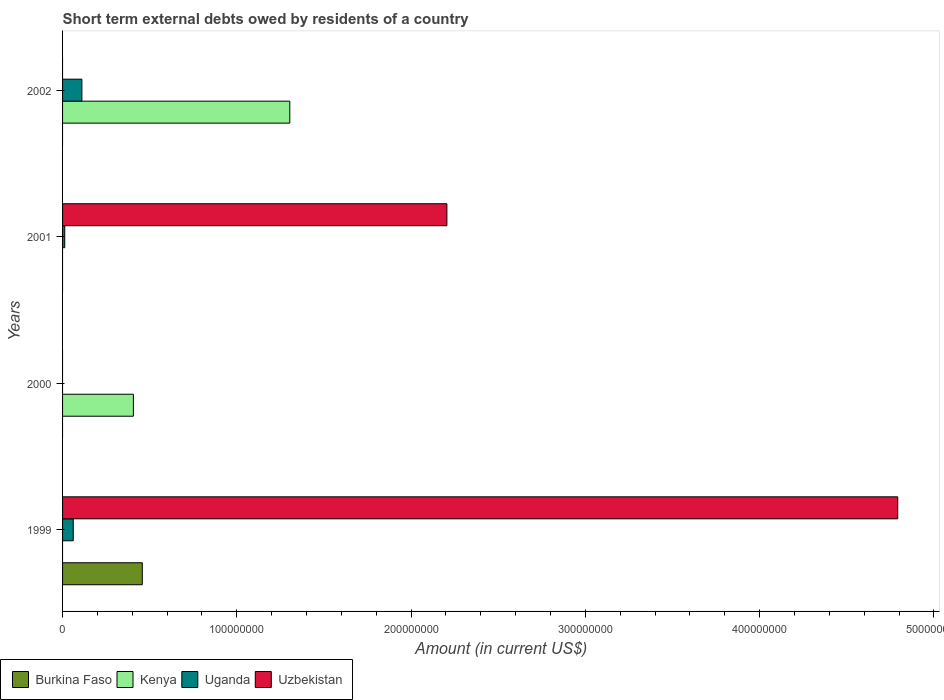Are the number of bars on each tick of the Y-axis equal?
Provide a succinct answer. No. How many bars are there on the 4th tick from the top?
Provide a short and direct response. 3. What is the amount of short-term external debts owed by residents in Kenya in 2002?
Make the answer very short. 1.30e+08. Across all years, what is the maximum amount of short-term external debts owed by residents in Uzbekistan?
Your answer should be compact. 4.79e+08. In which year was the amount of short-term external debts owed by residents in Uganda maximum?
Make the answer very short. 2002. What is the total amount of short-term external debts owed by residents in Uganda in the graph?
Provide a short and direct response. 1.85e+07. What is the difference between the amount of short-term external debts owed by residents in Uganda in 1999 and that in 2002?
Make the answer very short. -4.96e+06. What is the difference between the amount of short-term external debts owed by residents in Uganda in 2000 and the amount of short-term external debts owed by residents in Burkina Faso in 1999?
Offer a very short reply. -4.58e+07. What is the average amount of short-term external debts owed by residents in Uzbekistan per year?
Make the answer very short. 1.75e+08. In the year 2002, what is the difference between the amount of short-term external debts owed by residents in Kenya and amount of short-term external debts owed by residents in Uganda?
Ensure brevity in your answer.  1.19e+08. What is the ratio of the amount of short-term external debts owed by residents in Kenya in 2000 to that in 2002?
Offer a terse response. 0.31. What is the difference between the highest and the second highest amount of short-term external debts owed by residents in Uganda?
Your answer should be very brief. 4.96e+06. What is the difference between the highest and the lowest amount of short-term external debts owed by residents in Uganda?
Provide a short and direct response. 1.11e+07. In how many years, is the amount of short-term external debts owed by residents in Uzbekistan greater than the average amount of short-term external debts owed by residents in Uzbekistan taken over all years?
Ensure brevity in your answer.  2. Is the sum of the amount of short-term external debts owed by residents in Kenya in 2000 and 2002 greater than the maximum amount of short-term external debts owed by residents in Uganda across all years?
Provide a short and direct response. Yes. Is it the case that in every year, the sum of the amount of short-term external debts owed by residents in Uganda and amount of short-term external debts owed by residents in Burkina Faso is greater than the sum of amount of short-term external debts owed by residents in Uzbekistan and amount of short-term external debts owed by residents in Kenya?
Offer a terse response. No. Is it the case that in every year, the sum of the amount of short-term external debts owed by residents in Uganda and amount of short-term external debts owed by residents in Kenya is greater than the amount of short-term external debts owed by residents in Burkina Faso?
Your answer should be very brief. No. How many bars are there?
Give a very brief answer. 8. Are all the bars in the graph horizontal?
Provide a succinct answer. Yes. How many years are there in the graph?
Offer a terse response. 4. Does the graph contain any zero values?
Your response must be concise. Yes. How many legend labels are there?
Your response must be concise. 4. What is the title of the graph?
Keep it short and to the point. Short term external debts owed by residents of a country. Does "Fragile and conflict affected situations" appear as one of the legend labels in the graph?
Ensure brevity in your answer.  No. What is the label or title of the Y-axis?
Provide a succinct answer. Years. What is the Amount (in current US$) in Burkina Faso in 1999?
Offer a very short reply. 4.58e+07. What is the Amount (in current US$) in Uganda in 1999?
Your response must be concise. 6.13e+06. What is the Amount (in current US$) of Uzbekistan in 1999?
Your answer should be compact. 4.79e+08. What is the Amount (in current US$) of Burkina Faso in 2000?
Offer a terse response. 0. What is the Amount (in current US$) of Kenya in 2000?
Keep it short and to the point. 4.06e+07. What is the Amount (in current US$) of Kenya in 2001?
Provide a succinct answer. 0. What is the Amount (in current US$) in Uganda in 2001?
Provide a succinct answer. 1.24e+06. What is the Amount (in current US$) in Uzbekistan in 2001?
Offer a very short reply. 2.21e+08. What is the Amount (in current US$) of Kenya in 2002?
Offer a very short reply. 1.30e+08. What is the Amount (in current US$) in Uganda in 2002?
Offer a terse response. 1.11e+07. What is the Amount (in current US$) of Uzbekistan in 2002?
Keep it short and to the point. 0. Across all years, what is the maximum Amount (in current US$) of Burkina Faso?
Your answer should be very brief. 4.58e+07. Across all years, what is the maximum Amount (in current US$) in Kenya?
Ensure brevity in your answer.  1.30e+08. Across all years, what is the maximum Amount (in current US$) in Uganda?
Make the answer very short. 1.11e+07. Across all years, what is the maximum Amount (in current US$) of Uzbekistan?
Your answer should be very brief. 4.79e+08. Across all years, what is the minimum Amount (in current US$) of Kenya?
Your answer should be very brief. 0. What is the total Amount (in current US$) of Burkina Faso in the graph?
Provide a succinct answer. 4.58e+07. What is the total Amount (in current US$) in Kenya in the graph?
Ensure brevity in your answer.  1.71e+08. What is the total Amount (in current US$) of Uganda in the graph?
Your answer should be very brief. 1.85e+07. What is the total Amount (in current US$) of Uzbekistan in the graph?
Give a very brief answer. 7.00e+08. What is the difference between the Amount (in current US$) in Uganda in 1999 and that in 2001?
Offer a terse response. 4.89e+06. What is the difference between the Amount (in current US$) in Uzbekistan in 1999 and that in 2001?
Give a very brief answer. 2.59e+08. What is the difference between the Amount (in current US$) of Uganda in 1999 and that in 2002?
Offer a very short reply. -4.96e+06. What is the difference between the Amount (in current US$) of Kenya in 2000 and that in 2002?
Your response must be concise. -8.97e+07. What is the difference between the Amount (in current US$) of Uganda in 2001 and that in 2002?
Your response must be concise. -9.85e+06. What is the difference between the Amount (in current US$) in Burkina Faso in 1999 and the Amount (in current US$) in Kenya in 2000?
Your answer should be compact. 5.11e+06. What is the difference between the Amount (in current US$) of Burkina Faso in 1999 and the Amount (in current US$) of Uganda in 2001?
Provide a succinct answer. 4.45e+07. What is the difference between the Amount (in current US$) of Burkina Faso in 1999 and the Amount (in current US$) of Uzbekistan in 2001?
Provide a succinct answer. -1.75e+08. What is the difference between the Amount (in current US$) in Uganda in 1999 and the Amount (in current US$) in Uzbekistan in 2001?
Keep it short and to the point. -2.14e+08. What is the difference between the Amount (in current US$) of Burkina Faso in 1999 and the Amount (in current US$) of Kenya in 2002?
Provide a short and direct response. -8.46e+07. What is the difference between the Amount (in current US$) in Burkina Faso in 1999 and the Amount (in current US$) in Uganda in 2002?
Keep it short and to the point. 3.47e+07. What is the difference between the Amount (in current US$) in Kenya in 2000 and the Amount (in current US$) in Uganda in 2001?
Provide a succinct answer. 3.94e+07. What is the difference between the Amount (in current US$) of Kenya in 2000 and the Amount (in current US$) of Uzbekistan in 2001?
Make the answer very short. -1.80e+08. What is the difference between the Amount (in current US$) in Kenya in 2000 and the Amount (in current US$) in Uganda in 2002?
Provide a short and direct response. 2.96e+07. What is the average Amount (in current US$) in Burkina Faso per year?
Your response must be concise. 1.14e+07. What is the average Amount (in current US$) in Kenya per year?
Provide a short and direct response. 4.28e+07. What is the average Amount (in current US$) in Uganda per year?
Provide a succinct answer. 4.62e+06. What is the average Amount (in current US$) in Uzbekistan per year?
Provide a succinct answer. 1.75e+08. In the year 1999, what is the difference between the Amount (in current US$) in Burkina Faso and Amount (in current US$) in Uganda?
Your response must be concise. 3.96e+07. In the year 1999, what is the difference between the Amount (in current US$) of Burkina Faso and Amount (in current US$) of Uzbekistan?
Your response must be concise. -4.33e+08. In the year 1999, what is the difference between the Amount (in current US$) in Uganda and Amount (in current US$) in Uzbekistan?
Make the answer very short. -4.73e+08. In the year 2001, what is the difference between the Amount (in current US$) in Uganda and Amount (in current US$) in Uzbekistan?
Your answer should be compact. -2.19e+08. In the year 2002, what is the difference between the Amount (in current US$) of Kenya and Amount (in current US$) of Uganda?
Provide a short and direct response. 1.19e+08. What is the ratio of the Amount (in current US$) in Uganda in 1999 to that in 2001?
Give a very brief answer. 4.94. What is the ratio of the Amount (in current US$) of Uzbekistan in 1999 to that in 2001?
Keep it short and to the point. 2.17. What is the ratio of the Amount (in current US$) in Uganda in 1999 to that in 2002?
Your answer should be compact. 0.55. What is the ratio of the Amount (in current US$) in Kenya in 2000 to that in 2002?
Ensure brevity in your answer.  0.31. What is the ratio of the Amount (in current US$) of Uganda in 2001 to that in 2002?
Give a very brief answer. 0.11. What is the difference between the highest and the second highest Amount (in current US$) of Uganda?
Make the answer very short. 4.96e+06. What is the difference between the highest and the lowest Amount (in current US$) in Burkina Faso?
Keep it short and to the point. 4.58e+07. What is the difference between the highest and the lowest Amount (in current US$) in Kenya?
Provide a succinct answer. 1.30e+08. What is the difference between the highest and the lowest Amount (in current US$) in Uganda?
Your answer should be compact. 1.11e+07. What is the difference between the highest and the lowest Amount (in current US$) in Uzbekistan?
Keep it short and to the point. 4.79e+08. 